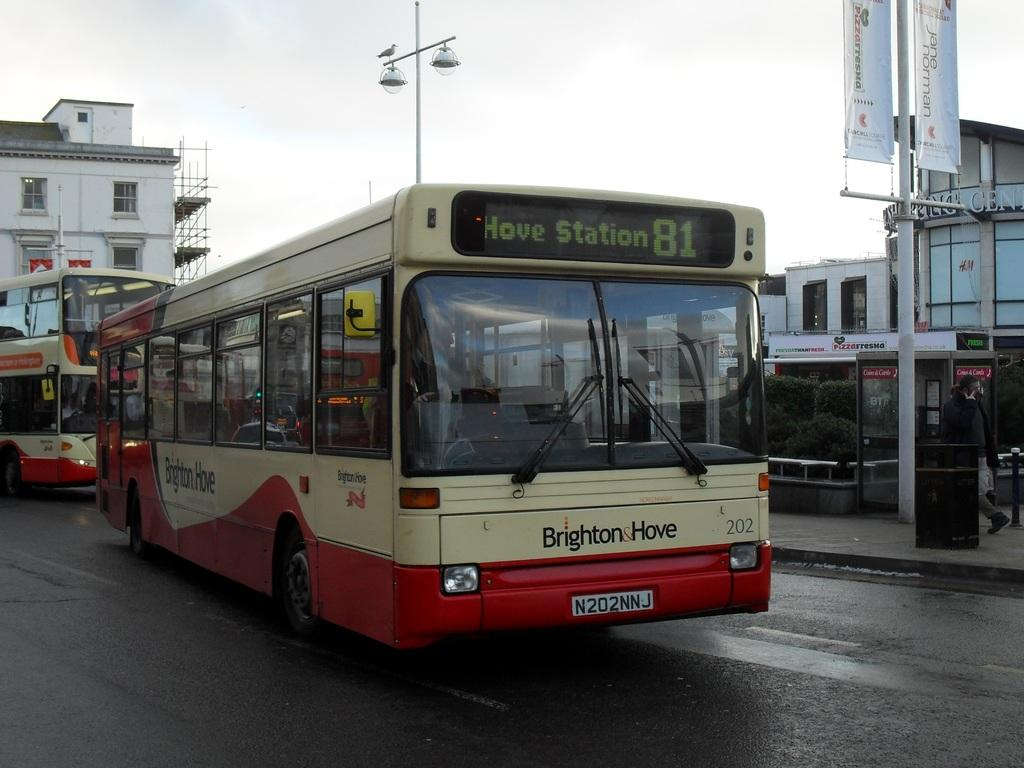What type of vehicles are present in the image? There are buses in the image. Where are the buses located? The buses are on the road. How many beds are visible in the image? There are no beds present in the image; it features buses on the road. What time does the alarm go off in the image? There is no alarm present in the image. 